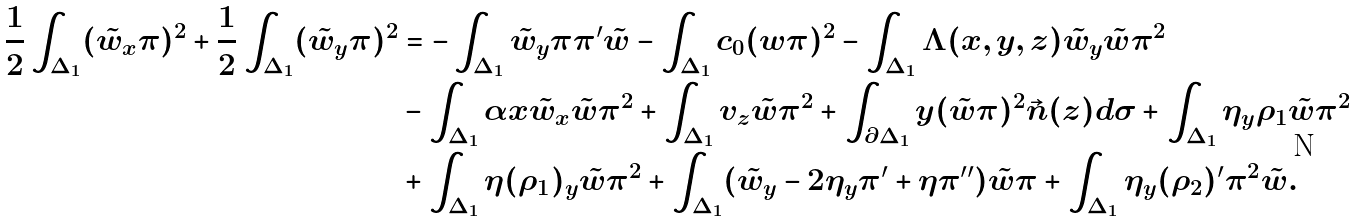<formula> <loc_0><loc_0><loc_500><loc_500>\frac { 1 } { 2 } \int _ { \Delta _ { 1 } } ( \tilde { w } _ { x } \pi ) ^ { 2 } + \frac { 1 } { 2 } \int _ { \Delta _ { 1 } } ( \tilde { w } _ { y } \pi ) ^ { 2 } & = - \int _ { \Delta _ { 1 } } \tilde { w } _ { y } \pi \pi ^ { \prime } \tilde { w } - \int _ { \Delta _ { 1 } } c _ { 0 } ( w \pi ) ^ { 2 } - \int _ { \Delta _ { 1 } } \Lambda ( x , y , z ) \tilde { w } _ { y } \tilde { w } \pi ^ { 2 } \\ & - \int _ { \Delta _ { 1 } } \alpha x \tilde { w } _ { x } \tilde { w } \pi ^ { 2 } + \int _ { \Delta _ { 1 } } v _ { z } \tilde { w } \pi ^ { 2 } + \int _ { \partial \Delta _ { 1 } } y ( \tilde { w } \pi ) ^ { 2 } \vec { n } ( z ) d \sigma + \int _ { \Delta _ { 1 } } \eta _ { y } \rho _ { 1 } \tilde { w } \pi ^ { 2 } \\ & + \int _ { \Delta _ { 1 } } \eta ( \rho _ { 1 } ) _ { y } \tilde { w } \pi ^ { 2 } + \int _ { \Delta _ { 1 } } ( \tilde { w } _ { y } - 2 \eta _ { y } \pi ^ { \prime } + \eta \pi ^ { \prime \prime } ) \tilde { w } \pi + \int _ { \Delta _ { 1 } } \eta _ { y } ( \rho _ { 2 } ) ^ { \prime } \pi ^ { 2 } \tilde { w } .</formula> 